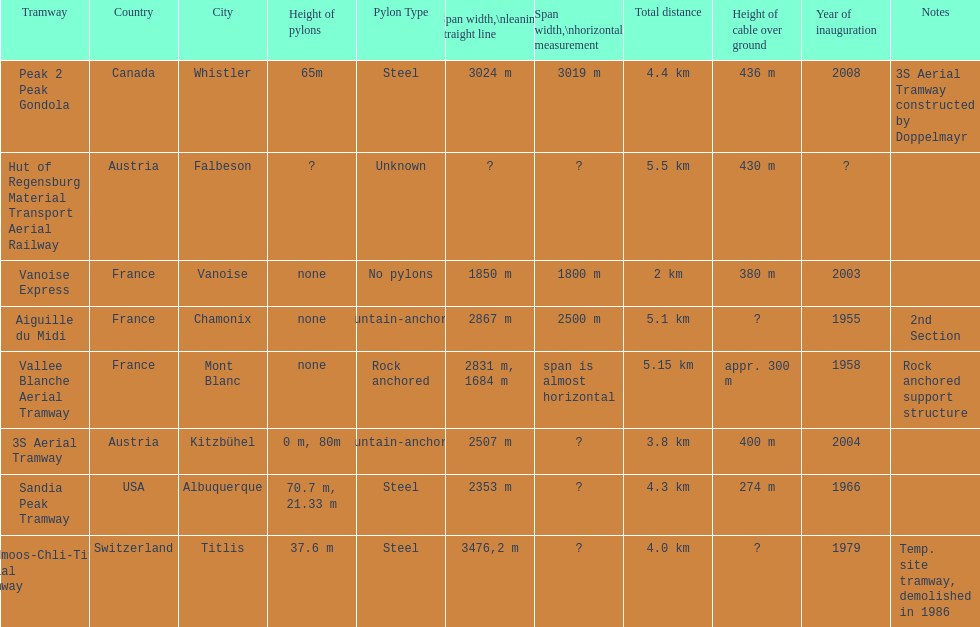What is the additional length of the peak 2 peak gondola compared to the 32 aerial tramway? 517. 